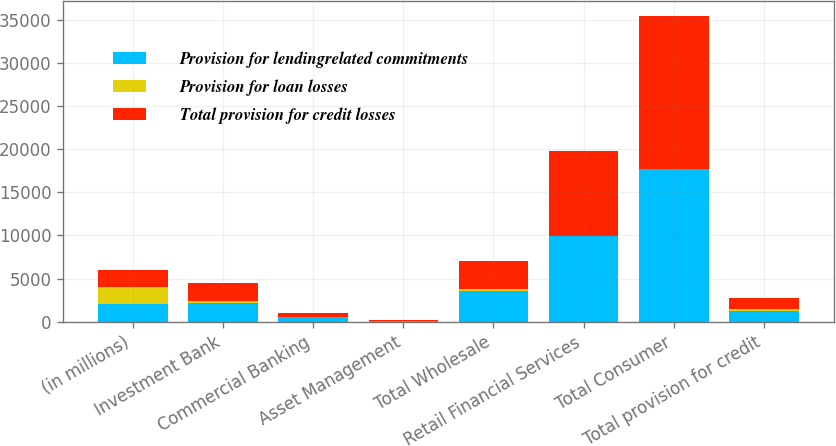<chart> <loc_0><loc_0><loc_500><loc_500><stacked_bar_chart><ecel><fcel>(in millions)<fcel>Investment Bank<fcel>Commercial Banking<fcel>Asset Management<fcel>Total Wholesale<fcel>Retail Financial Services<fcel>Total Consumer<fcel>Total provision for credit<nl><fcel>Provision for lendingrelated commitments<fcel>2008<fcel>2216<fcel>505<fcel>87<fcel>3536<fcel>9906<fcel>17701<fcel>1256.5<nl><fcel>Provision for loan losses<fcel>2008<fcel>201<fcel>41<fcel>2<fcel>209<fcel>1<fcel>49<fcel>258<nl><fcel>Total provision for credit losses<fcel>2008<fcel>2015<fcel>464<fcel>85<fcel>3327<fcel>9905<fcel>17652<fcel>1256.5<nl></chart> 